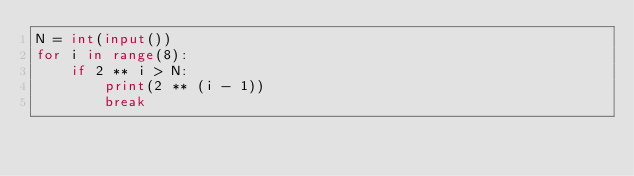Convert code to text. <code><loc_0><loc_0><loc_500><loc_500><_Python_>N = int(input())
for i in range(8):
    if 2 ** i > N:
        print(2 ** (i - 1))
        break</code> 